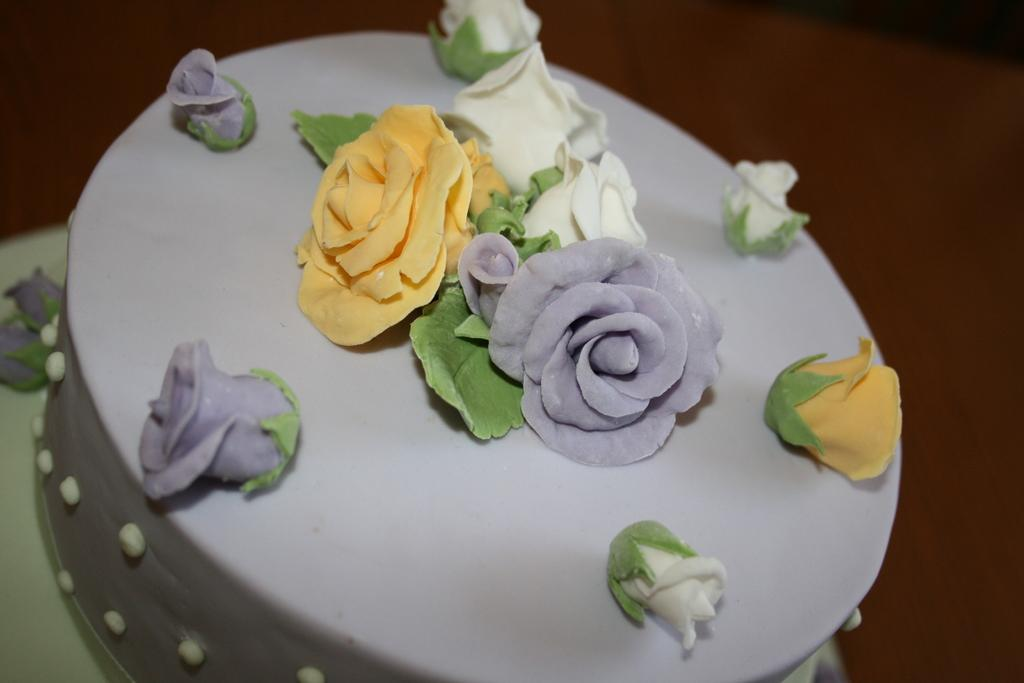What is the main subject of the image? There is a cake in the image. Can you describe the design on the cake? The cake has a rose flower design. What type of space exploration is depicted on the cake? There is no space exploration depicted on the cake; it features a rose flower design. How many bites have been taken out of the cake in the image? There is no indication of any bites taken out of the cake in the image. 